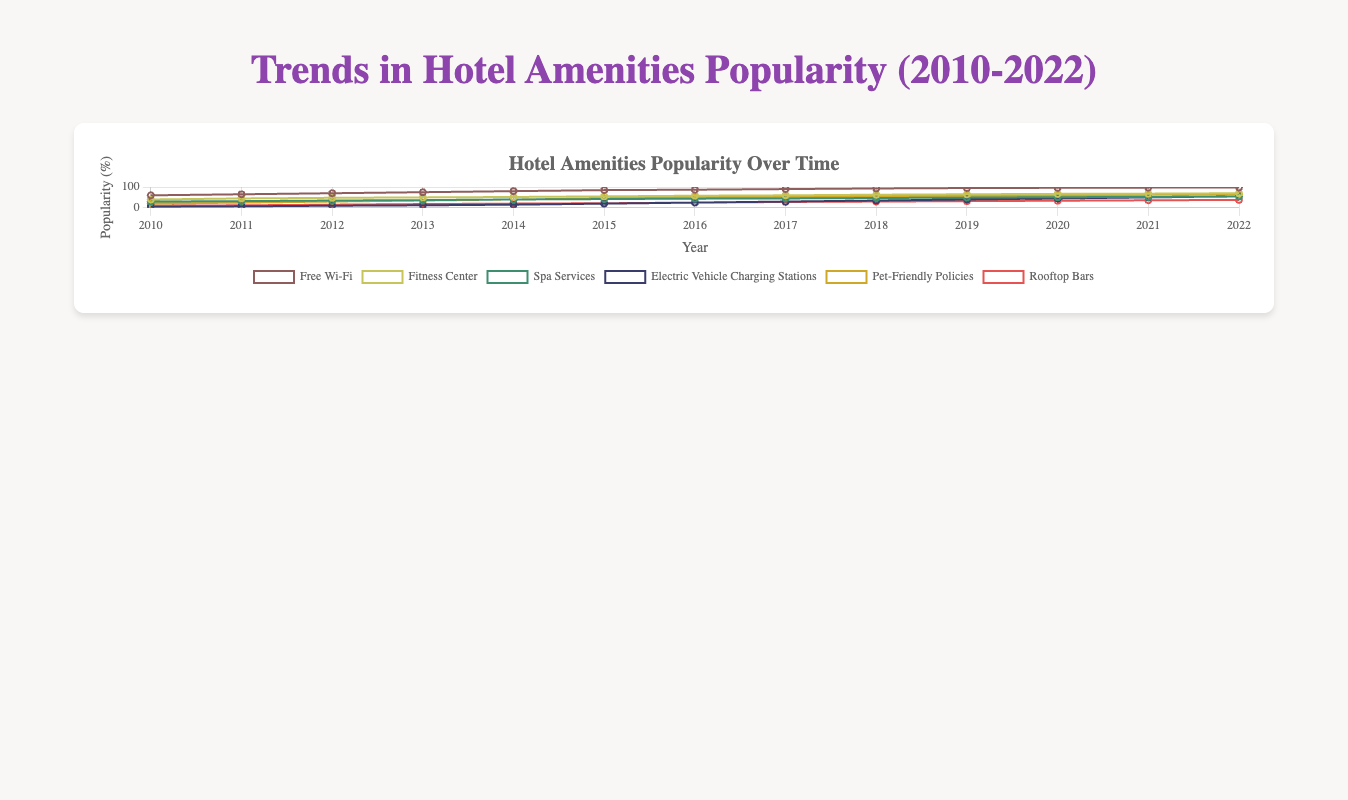What is the trend of Free Wi-Fi popularity from 2010 to 2022? From 2010 to 2022, look at the line representing Free Wi-Fi, it consistently increases each year from 60% to 98%.
Answer: The popularity of Free Wi-Fi continuously increases Which hotel amenity saw the most consistent growth over the years? Compare the slopes of the lines representing each amenity. Free Wi-Fi shows the most consistent and steepest upward trend without any decline throughout the years.
Answer: Free Wi-Fi Between 2010 and 2022, which year did Fitness Centers experience the highest increase in popularity? By looking at the slope of the Fitness Center line from year to year, the steepest slope (highest increase) occurs between 2010 and 2011, where it jumps from 40% to 45%.
Answer: 2011 Which amenity had the least popularity in 2010, and what was its percentage? Examine the starting points of the lines for each amenity in 2010. Electric Vehicle Charging Stations have a starting point at 5%, the lowest among the amenities.
Answer: Electric Vehicle Charging Stations, 5% What is the percentage difference in popularity between Spa Services and Rooftop Bars in 2015? Identify the popularity percentages for Spa Services and Rooftop Bars in 2015, which are 42% and 22% respectively. The difference is 42% - 22% = 20%.
Answer: 20% Which amenities became equally popular in any year between 2010 and 2022, and what year was it? Look for any intersecting points of the lines. Fitness Center and Pet-Friendly Policies both reach 50% popularity in 2016.
Answer: Fitness Center and Pet-Friendly Policies, 2016 By how much did the popularity of Electric Vehicle Charging Stations increase from 2010 to 2022? Subtract the percentage in 2010 from the percentage in 2022: 55% - 5% = 50%.
Answer: 50% In 2020, which amenity was more popular: Fitness Centers or Pet-Friendly Policies? Compare the 2020 markers for Fitness Centers and Pet-Friendly Policies. Fitness Centers have a popularity of 67%, whereas Pet-Friendly Policies have 60%. Thus, Fitness Centers were more popular.
Answer: Fitness Centers Between 2018 and 2019, which amenity had the largest percentage increase, and by how much? Compare the slopes of the lines from 2018 to 2019. Electric Vehicle Charging Stations had the steepest increase: from 35% to 40%, an increase of 5%.
Answer: Electric Vehicle Charging Stations, 5% What is the average popularity of Rooftop Bars between 2010 and 2022? Sum up the popularity percentages for Rooftop Bars (10, 12, 15, 18, 20, 22, 25, 28, 30, 32, 34, 36, 38) and divide by the number of years (13). The sum is 300, so the average is 300/13 ≈ 23.08.
Answer: 23.08 